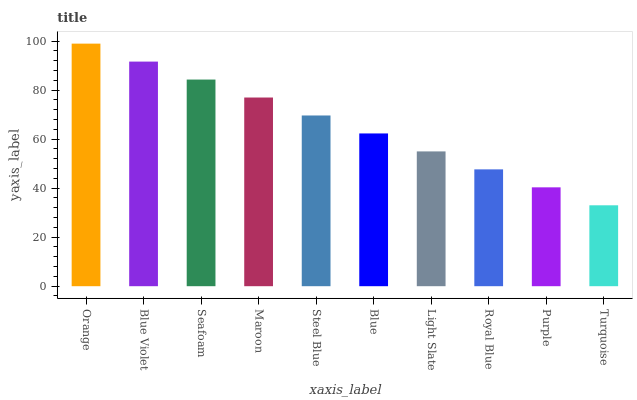Is Turquoise the minimum?
Answer yes or no. Yes. Is Orange the maximum?
Answer yes or no. Yes. Is Blue Violet the minimum?
Answer yes or no. No. Is Blue Violet the maximum?
Answer yes or no. No. Is Orange greater than Blue Violet?
Answer yes or no. Yes. Is Blue Violet less than Orange?
Answer yes or no. Yes. Is Blue Violet greater than Orange?
Answer yes or no. No. Is Orange less than Blue Violet?
Answer yes or no. No. Is Steel Blue the high median?
Answer yes or no. Yes. Is Blue the low median?
Answer yes or no. Yes. Is Royal Blue the high median?
Answer yes or no. No. Is Orange the low median?
Answer yes or no. No. 